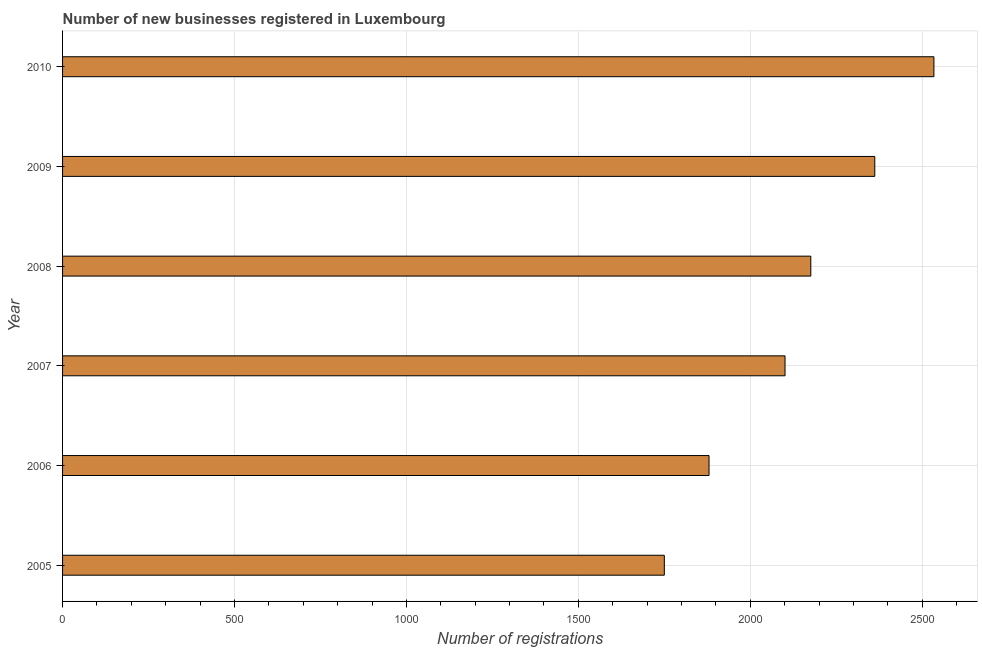Does the graph contain any zero values?
Your answer should be very brief. No. What is the title of the graph?
Give a very brief answer. Number of new businesses registered in Luxembourg. What is the label or title of the X-axis?
Your response must be concise. Number of registrations. What is the label or title of the Y-axis?
Ensure brevity in your answer.  Year. What is the number of new business registrations in 2009?
Your answer should be compact. 2362. Across all years, what is the maximum number of new business registrations?
Your answer should be very brief. 2534. Across all years, what is the minimum number of new business registrations?
Your answer should be compact. 1750. In which year was the number of new business registrations maximum?
Keep it short and to the point. 2010. In which year was the number of new business registrations minimum?
Keep it short and to the point. 2005. What is the sum of the number of new business registrations?
Your answer should be compact. 1.28e+04. What is the difference between the number of new business registrations in 2006 and 2009?
Offer a very short reply. -482. What is the average number of new business registrations per year?
Ensure brevity in your answer.  2133. What is the median number of new business registrations?
Offer a terse response. 2138.5. What is the ratio of the number of new business registrations in 2005 to that in 2006?
Your answer should be compact. 0.93. Is the difference between the number of new business registrations in 2005 and 2010 greater than the difference between any two years?
Your answer should be compact. Yes. What is the difference between the highest and the second highest number of new business registrations?
Provide a succinct answer. 172. What is the difference between the highest and the lowest number of new business registrations?
Your answer should be very brief. 784. Are all the bars in the graph horizontal?
Offer a terse response. Yes. What is the difference between two consecutive major ticks on the X-axis?
Make the answer very short. 500. What is the Number of registrations of 2005?
Make the answer very short. 1750. What is the Number of registrations in 2006?
Ensure brevity in your answer.  1880. What is the Number of registrations of 2007?
Keep it short and to the point. 2101. What is the Number of registrations of 2008?
Make the answer very short. 2176. What is the Number of registrations of 2009?
Ensure brevity in your answer.  2362. What is the Number of registrations in 2010?
Provide a short and direct response. 2534. What is the difference between the Number of registrations in 2005 and 2006?
Provide a short and direct response. -130. What is the difference between the Number of registrations in 2005 and 2007?
Your answer should be compact. -351. What is the difference between the Number of registrations in 2005 and 2008?
Your response must be concise. -426. What is the difference between the Number of registrations in 2005 and 2009?
Provide a succinct answer. -612. What is the difference between the Number of registrations in 2005 and 2010?
Offer a very short reply. -784. What is the difference between the Number of registrations in 2006 and 2007?
Your answer should be compact. -221. What is the difference between the Number of registrations in 2006 and 2008?
Your answer should be very brief. -296. What is the difference between the Number of registrations in 2006 and 2009?
Provide a short and direct response. -482. What is the difference between the Number of registrations in 2006 and 2010?
Offer a very short reply. -654. What is the difference between the Number of registrations in 2007 and 2008?
Provide a short and direct response. -75. What is the difference between the Number of registrations in 2007 and 2009?
Keep it short and to the point. -261. What is the difference between the Number of registrations in 2007 and 2010?
Make the answer very short. -433. What is the difference between the Number of registrations in 2008 and 2009?
Your response must be concise. -186. What is the difference between the Number of registrations in 2008 and 2010?
Provide a succinct answer. -358. What is the difference between the Number of registrations in 2009 and 2010?
Your response must be concise. -172. What is the ratio of the Number of registrations in 2005 to that in 2007?
Your response must be concise. 0.83. What is the ratio of the Number of registrations in 2005 to that in 2008?
Provide a short and direct response. 0.8. What is the ratio of the Number of registrations in 2005 to that in 2009?
Give a very brief answer. 0.74. What is the ratio of the Number of registrations in 2005 to that in 2010?
Ensure brevity in your answer.  0.69. What is the ratio of the Number of registrations in 2006 to that in 2007?
Make the answer very short. 0.9. What is the ratio of the Number of registrations in 2006 to that in 2008?
Ensure brevity in your answer.  0.86. What is the ratio of the Number of registrations in 2006 to that in 2009?
Ensure brevity in your answer.  0.8. What is the ratio of the Number of registrations in 2006 to that in 2010?
Your answer should be very brief. 0.74. What is the ratio of the Number of registrations in 2007 to that in 2008?
Ensure brevity in your answer.  0.97. What is the ratio of the Number of registrations in 2007 to that in 2009?
Provide a short and direct response. 0.89. What is the ratio of the Number of registrations in 2007 to that in 2010?
Provide a succinct answer. 0.83. What is the ratio of the Number of registrations in 2008 to that in 2009?
Your response must be concise. 0.92. What is the ratio of the Number of registrations in 2008 to that in 2010?
Ensure brevity in your answer.  0.86. What is the ratio of the Number of registrations in 2009 to that in 2010?
Provide a succinct answer. 0.93. 